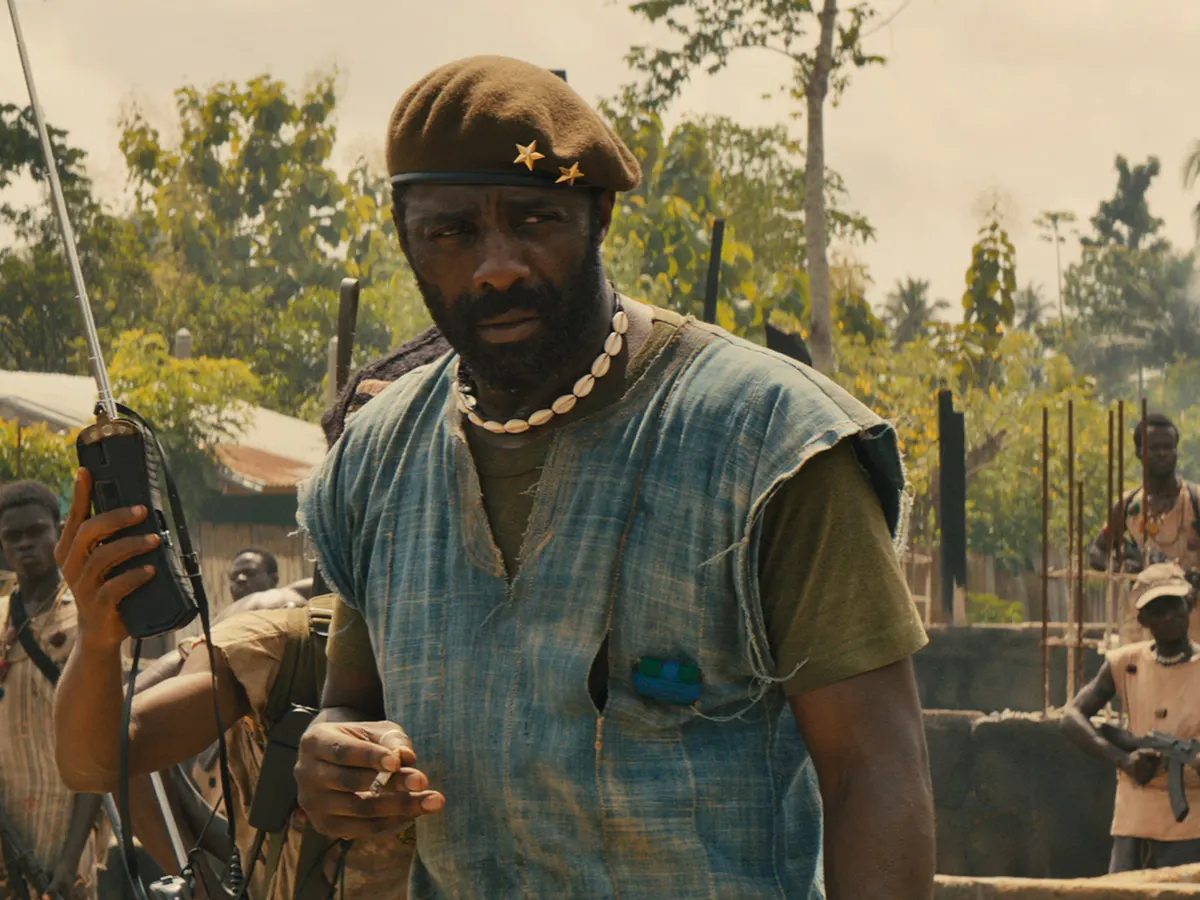Imagine the scene is a pivotal moment in an interactive storytelling game. What choices might the player have at this point? As the player takes on the role of a young soldier under the Commandant's leadership, they are faced with critical choices at this pivotal moment:

1. **Follow Orders**: Adhere to the Commandant’s strategy and participate in the planned assault, boosting your standing within the group but risking personal danger.
2. **Suggest an Alternative Plan**: Propose a more cautious approach to minimize casualties, potentially gaining the Commandant's respect but causing friction with more aggressive comrades.
3. **Seek Out Allies**: Take a brief detour to scout for potential allies in the surrounding area, which could provide additional support but delay the mission.
4. **Desert the Group**: Secretly slip away from the group to seek safety, leading to personal survival but betraying the trust of your fellow soldiers.

Each choice will affect the unfolding narrative, including relationships with other characters, the group’s morale, and the outcome of the mission. 